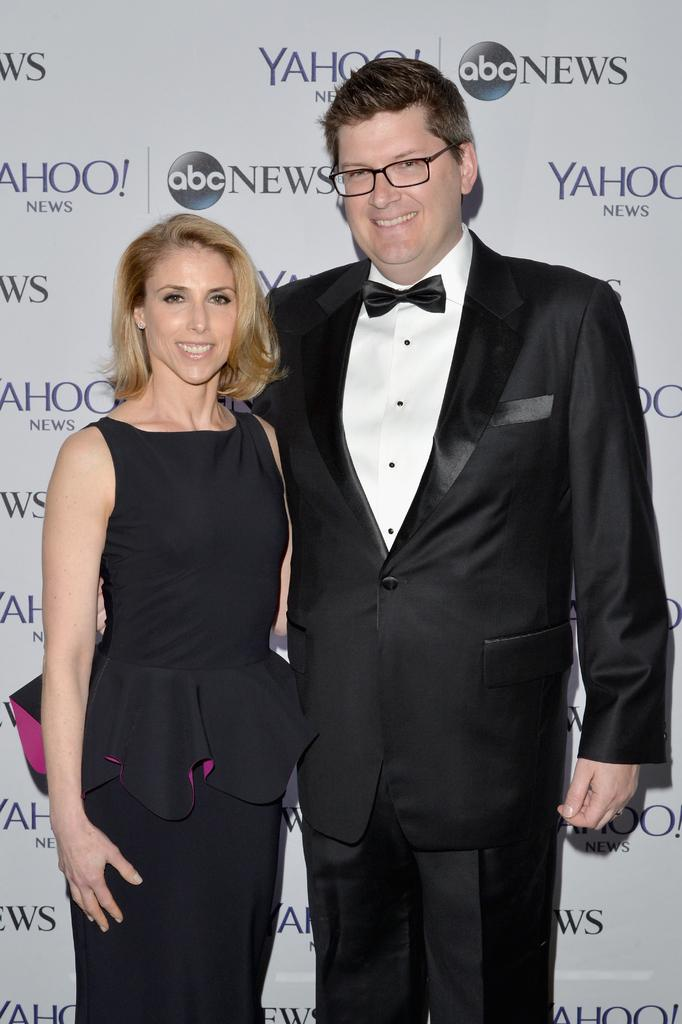<image>
Relay a brief, clear account of the picture shown. A couple is posing in front of a wall with Yahoo News and ABC news written on it. 